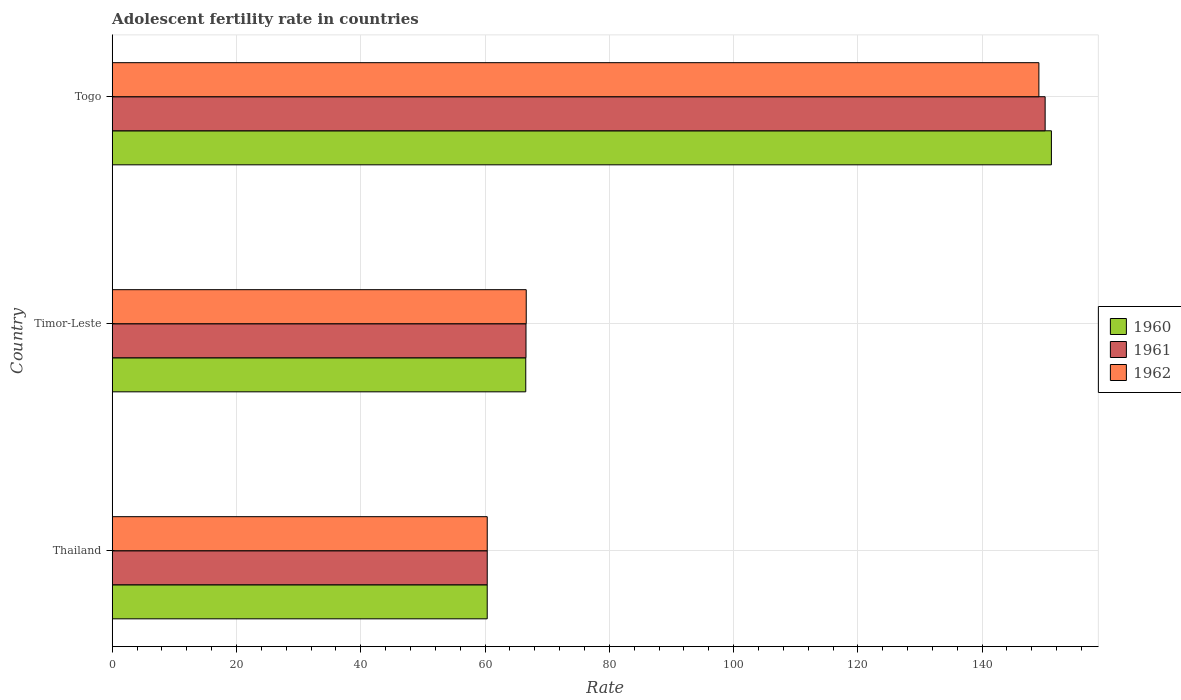How many different coloured bars are there?
Offer a terse response. 3. How many groups of bars are there?
Ensure brevity in your answer.  3. Are the number of bars per tick equal to the number of legend labels?
Make the answer very short. Yes. Are the number of bars on each tick of the Y-axis equal?
Your answer should be compact. Yes. What is the label of the 3rd group of bars from the top?
Give a very brief answer. Thailand. What is the adolescent fertility rate in 1962 in Togo?
Make the answer very short. 149.13. Across all countries, what is the maximum adolescent fertility rate in 1961?
Your response must be concise. 150.14. Across all countries, what is the minimum adolescent fertility rate in 1960?
Offer a very short reply. 60.35. In which country was the adolescent fertility rate in 1962 maximum?
Offer a very short reply. Togo. In which country was the adolescent fertility rate in 1962 minimum?
Make the answer very short. Thailand. What is the total adolescent fertility rate in 1960 in the graph?
Your response must be concise. 278.05. What is the difference between the adolescent fertility rate in 1961 in Timor-Leste and that in Togo?
Offer a terse response. -83.55. What is the difference between the adolescent fertility rate in 1962 in Thailand and the adolescent fertility rate in 1961 in Timor-Leste?
Offer a very short reply. -6.24. What is the average adolescent fertility rate in 1962 per country?
Keep it short and to the point. 92.04. What is the difference between the adolescent fertility rate in 1961 and adolescent fertility rate in 1960 in Timor-Leste?
Provide a succinct answer. 0.04. What is the ratio of the adolescent fertility rate in 1962 in Thailand to that in Togo?
Your response must be concise. 0.4. Is the adolescent fertility rate in 1960 in Timor-Leste less than that in Togo?
Ensure brevity in your answer.  Yes. What is the difference between the highest and the second highest adolescent fertility rate in 1960?
Your answer should be compact. 84.6. What is the difference between the highest and the lowest adolescent fertility rate in 1960?
Provide a short and direct response. 90.8. What does the 1st bar from the top in Timor-Leste represents?
Offer a very short reply. 1962. Is it the case that in every country, the sum of the adolescent fertility rate in 1962 and adolescent fertility rate in 1960 is greater than the adolescent fertility rate in 1961?
Give a very brief answer. Yes. How many countries are there in the graph?
Your answer should be very brief. 3. Are the values on the major ticks of X-axis written in scientific E-notation?
Provide a short and direct response. No. Does the graph contain any zero values?
Your answer should be compact. No. What is the title of the graph?
Give a very brief answer. Adolescent fertility rate in countries. What is the label or title of the X-axis?
Offer a terse response. Rate. What is the Rate of 1960 in Thailand?
Provide a short and direct response. 60.35. What is the Rate in 1961 in Thailand?
Give a very brief answer. 60.35. What is the Rate in 1962 in Thailand?
Keep it short and to the point. 60.35. What is the Rate in 1960 in Timor-Leste?
Make the answer very short. 66.55. What is the Rate of 1961 in Timor-Leste?
Make the answer very short. 66.59. What is the Rate in 1962 in Timor-Leste?
Give a very brief answer. 66.63. What is the Rate in 1960 in Togo?
Your answer should be compact. 151.15. What is the Rate of 1961 in Togo?
Offer a terse response. 150.14. What is the Rate of 1962 in Togo?
Ensure brevity in your answer.  149.13. Across all countries, what is the maximum Rate in 1960?
Your answer should be compact. 151.15. Across all countries, what is the maximum Rate in 1961?
Your response must be concise. 150.14. Across all countries, what is the maximum Rate in 1962?
Offer a terse response. 149.13. Across all countries, what is the minimum Rate in 1960?
Your answer should be compact. 60.35. Across all countries, what is the minimum Rate of 1961?
Your answer should be compact. 60.35. Across all countries, what is the minimum Rate in 1962?
Your answer should be very brief. 60.35. What is the total Rate of 1960 in the graph?
Provide a succinct answer. 278.05. What is the total Rate in 1961 in the graph?
Keep it short and to the point. 277.08. What is the total Rate in 1962 in the graph?
Your response must be concise. 276.11. What is the difference between the Rate of 1960 in Thailand and that in Timor-Leste?
Offer a very short reply. -6.2. What is the difference between the Rate of 1961 in Thailand and that in Timor-Leste?
Make the answer very short. -6.24. What is the difference between the Rate of 1962 in Thailand and that in Timor-Leste?
Ensure brevity in your answer.  -6.28. What is the difference between the Rate in 1960 in Thailand and that in Togo?
Ensure brevity in your answer.  -90.8. What is the difference between the Rate in 1961 in Thailand and that in Togo?
Provide a short and direct response. -89.79. What is the difference between the Rate of 1962 in Thailand and that in Togo?
Keep it short and to the point. -88.78. What is the difference between the Rate in 1960 in Timor-Leste and that in Togo?
Ensure brevity in your answer.  -84.6. What is the difference between the Rate of 1961 in Timor-Leste and that in Togo?
Offer a terse response. -83.55. What is the difference between the Rate of 1962 in Timor-Leste and that in Togo?
Offer a very short reply. -82.5. What is the difference between the Rate of 1960 in Thailand and the Rate of 1961 in Timor-Leste?
Offer a very short reply. -6.24. What is the difference between the Rate in 1960 in Thailand and the Rate in 1962 in Timor-Leste?
Provide a short and direct response. -6.28. What is the difference between the Rate in 1961 in Thailand and the Rate in 1962 in Timor-Leste?
Your answer should be compact. -6.28. What is the difference between the Rate in 1960 in Thailand and the Rate in 1961 in Togo?
Make the answer very short. -89.79. What is the difference between the Rate of 1960 in Thailand and the Rate of 1962 in Togo?
Offer a very short reply. -88.78. What is the difference between the Rate in 1961 in Thailand and the Rate in 1962 in Togo?
Ensure brevity in your answer.  -88.78. What is the difference between the Rate of 1960 in Timor-Leste and the Rate of 1961 in Togo?
Offer a terse response. -83.59. What is the difference between the Rate in 1960 in Timor-Leste and the Rate in 1962 in Togo?
Make the answer very short. -82.58. What is the difference between the Rate of 1961 in Timor-Leste and the Rate of 1962 in Togo?
Provide a short and direct response. -82.54. What is the average Rate in 1960 per country?
Provide a short and direct response. 92.68. What is the average Rate in 1961 per country?
Your response must be concise. 92.36. What is the average Rate in 1962 per country?
Ensure brevity in your answer.  92.04. What is the difference between the Rate of 1960 and Rate of 1961 in Thailand?
Ensure brevity in your answer.  -0. What is the difference between the Rate in 1960 and Rate in 1962 in Thailand?
Your answer should be very brief. -0. What is the difference between the Rate of 1961 and Rate of 1962 in Thailand?
Your answer should be compact. -0. What is the difference between the Rate of 1960 and Rate of 1961 in Timor-Leste?
Provide a succinct answer. -0.04. What is the difference between the Rate in 1960 and Rate in 1962 in Timor-Leste?
Give a very brief answer. -0.08. What is the difference between the Rate of 1961 and Rate of 1962 in Timor-Leste?
Ensure brevity in your answer.  -0.04. What is the difference between the Rate in 1960 and Rate in 1961 in Togo?
Offer a terse response. 1.01. What is the difference between the Rate of 1960 and Rate of 1962 in Togo?
Ensure brevity in your answer.  2.02. What is the difference between the Rate of 1961 and Rate of 1962 in Togo?
Your response must be concise. 1.01. What is the ratio of the Rate of 1960 in Thailand to that in Timor-Leste?
Your answer should be very brief. 0.91. What is the ratio of the Rate in 1961 in Thailand to that in Timor-Leste?
Offer a terse response. 0.91. What is the ratio of the Rate in 1962 in Thailand to that in Timor-Leste?
Give a very brief answer. 0.91. What is the ratio of the Rate of 1960 in Thailand to that in Togo?
Offer a very short reply. 0.4. What is the ratio of the Rate in 1961 in Thailand to that in Togo?
Offer a terse response. 0.4. What is the ratio of the Rate in 1962 in Thailand to that in Togo?
Ensure brevity in your answer.  0.4. What is the ratio of the Rate in 1960 in Timor-Leste to that in Togo?
Ensure brevity in your answer.  0.44. What is the ratio of the Rate of 1961 in Timor-Leste to that in Togo?
Keep it short and to the point. 0.44. What is the ratio of the Rate in 1962 in Timor-Leste to that in Togo?
Ensure brevity in your answer.  0.45. What is the difference between the highest and the second highest Rate of 1960?
Your response must be concise. 84.6. What is the difference between the highest and the second highest Rate of 1961?
Provide a succinct answer. 83.55. What is the difference between the highest and the second highest Rate of 1962?
Keep it short and to the point. 82.5. What is the difference between the highest and the lowest Rate of 1960?
Your answer should be compact. 90.8. What is the difference between the highest and the lowest Rate in 1961?
Your answer should be compact. 89.79. What is the difference between the highest and the lowest Rate in 1962?
Your answer should be very brief. 88.78. 